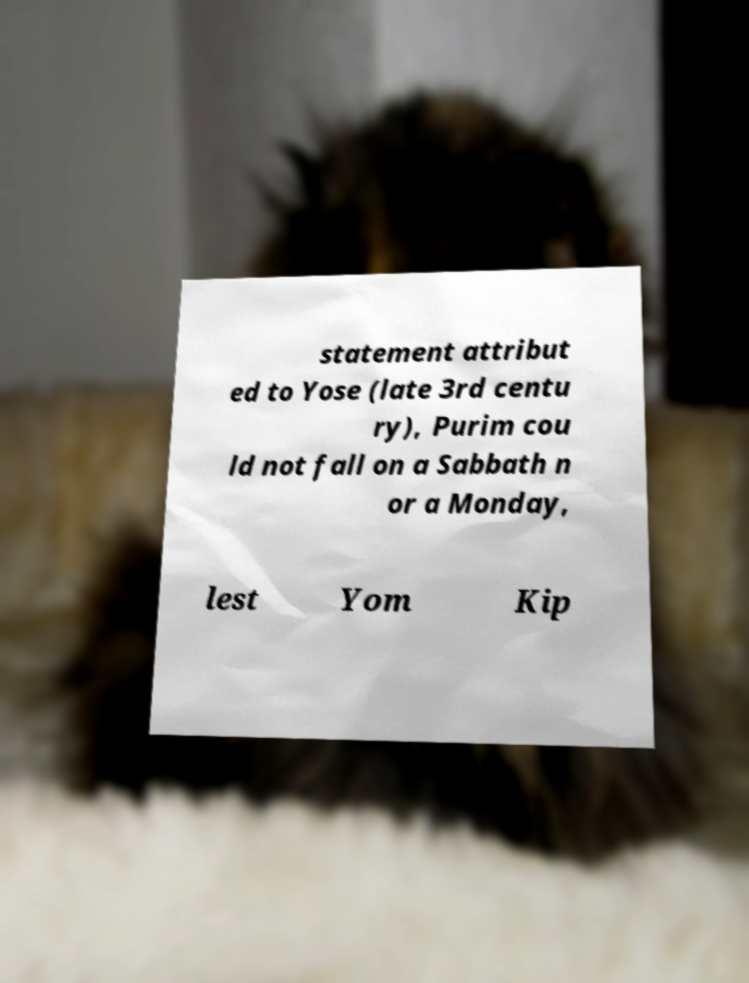Please identify and transcribe the text found in this image. statement attribut ed to Yose (late 3rd centu ry), Purim cou ld not fall on a Sabbath n or a Monday, lest Yom Kip 